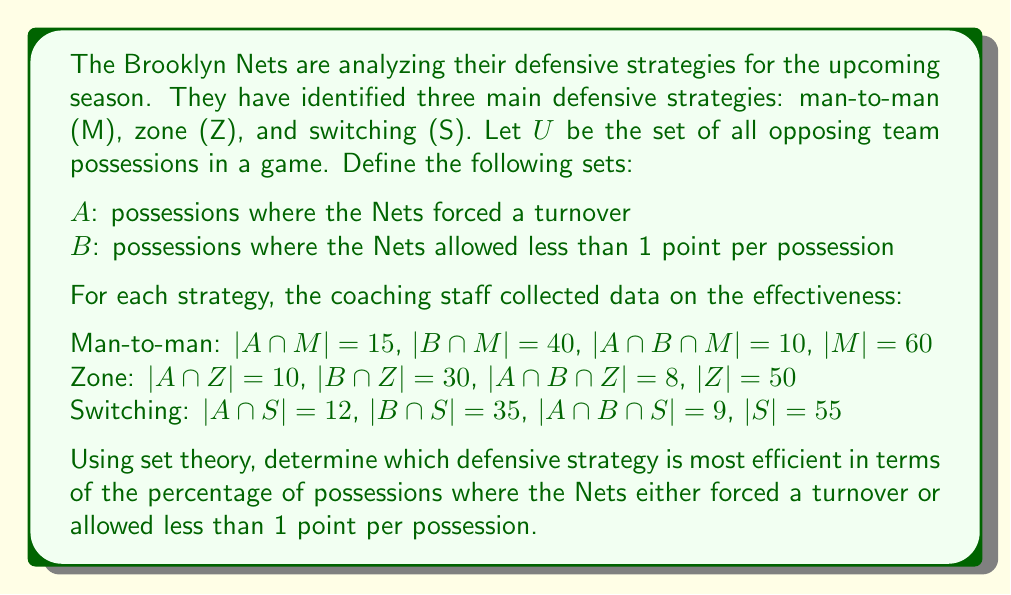Help me with this question. Let's approach this step-by-step using set theory:

1) For each strategy, we need to find $|(A \cup B) \cap X|$ where $X$ is the strategy (M, Z, or S). This represents the number of possessions where the defense either forced a turnover or allowed less than 1 point.

2) We can use the inclusion-exclusion principle:
   $|A \cup B| = |A| + |B| - |A \cap B|$

3) For each strategy:

   Man-to-man (M):
   $|(A \cup B) \cap M| = |A \cap M| + |B \cap M| - |A \cap B \cap M|$
   $= 15 + 40 - 10 = 45$

   Zone (Z):
   $|(A \cup B) \cap Z| = |A \cap Z| + |B \cap Z| - |A \cap B \cap Z|$
   $= 10 + 30 - 8 = 32$

   Switching (S):
   $|(A \cup B) \cap S| = |A \cap S| + |B \cap S| - |A \cap B \cap S|$
   $= 12 + 35 - 9 = 38$

4) Now, we need to calculate the percentage for each strategy:

   Man-to-man: $\frac{45}{60} \times 100\% = 75\%$
   Zone: $\frac{32}{50} \times 100\% = 64\%$
   Switching: $\frac{38}{55} \times 100\% \approx 69.09\%$

5) The strategy with the highest percentage is the most efficient.
Answer: The man-to-man defense is the most efficient strategy, with 75% of possessions resulting in either a turnover or less than 1 point allowed. 